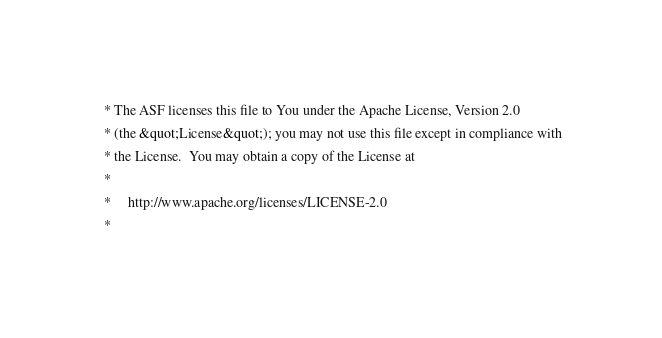<code> <loc_0><loc_0><loc_500><loc_500><_HTML_> * The ASF licenses this file to You under the Apache License, Version 2.0
 * (the &quot;License&quot;); you may not use this file except in compliance with
 * the License.  You may obtain a copy of the License at
 *
 *     http://www.apache.org/licenses/LICENSE-2.0
 *</code> 